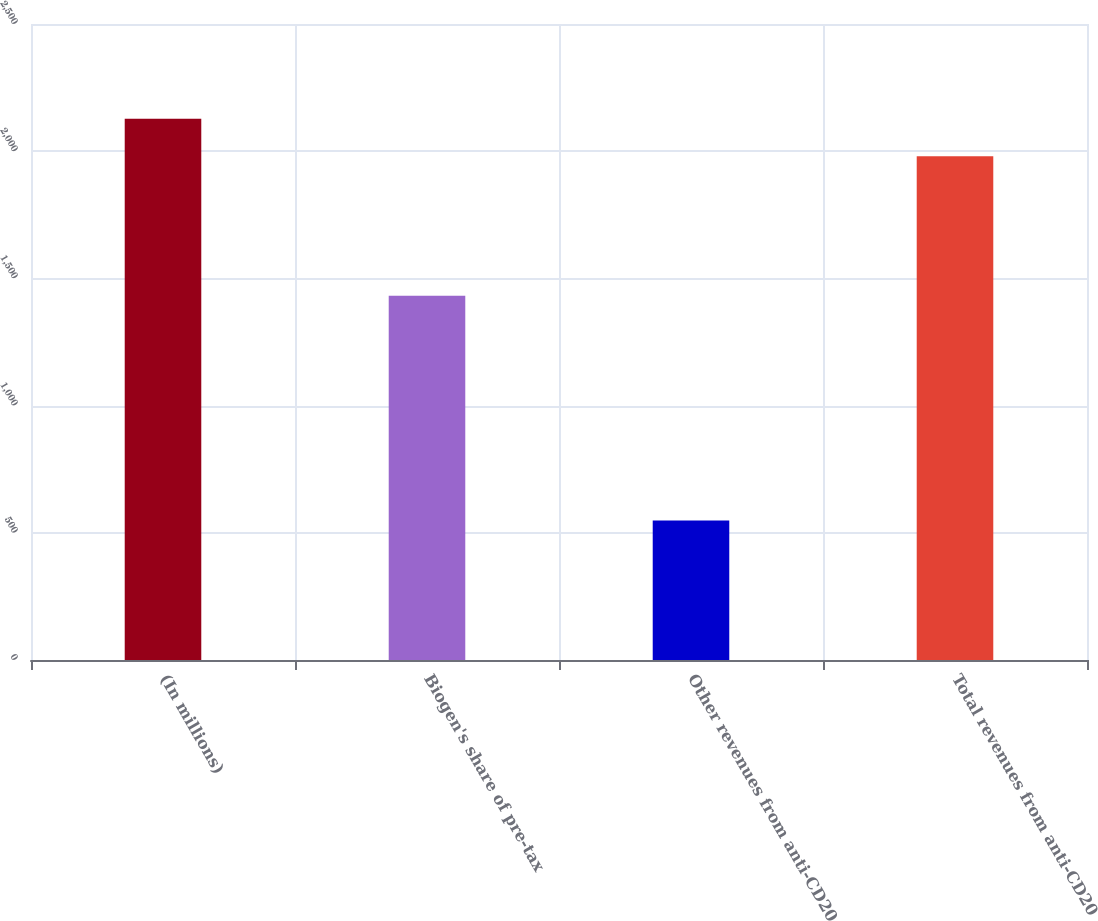Convert chart. <chart><loc_0><loc_0><loc_500><loc_500><bar_chart><fcel>(In millions)<fcel>Biogen's share of pre-tax<fcel>Other revenues from anti-CD20<fcel>Total revenues from anti-CD20<nl><fcel>2127.17<fcel>1431.9<fcel>548.3<fcel>1980.2<nl></chart> 